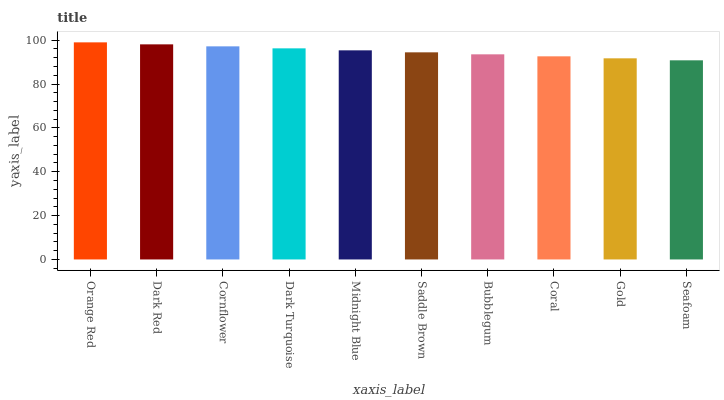Is Seafoam the minimum?
Answer yes or no. Yes. Is Orange Red the maximum?
Answer yes or no. Yes. Is Dark Red the minimum?
Answer yes or no. No. Is Dark Red the maximum?
Answer yes or no. No. Is Orange Red greater than Dark Red?
Answer yes or no. Yes. Is Dark Red less than Orange Red?
Answer yes or no. Yes. Is Dark Red greater than Orange Red?
Answer yes or no. No. Is Orange Red less than Dark Red?
Answer yes or no. No. Is Midnight Blue the high median?
Answer yes or no. Yes. Is Saddle Brown the low median?
Answer yes or no. Yes. Is Coral the high median?
Answer yes or no. No. Is Dark Red the low median?
Answer yes or no. No. 